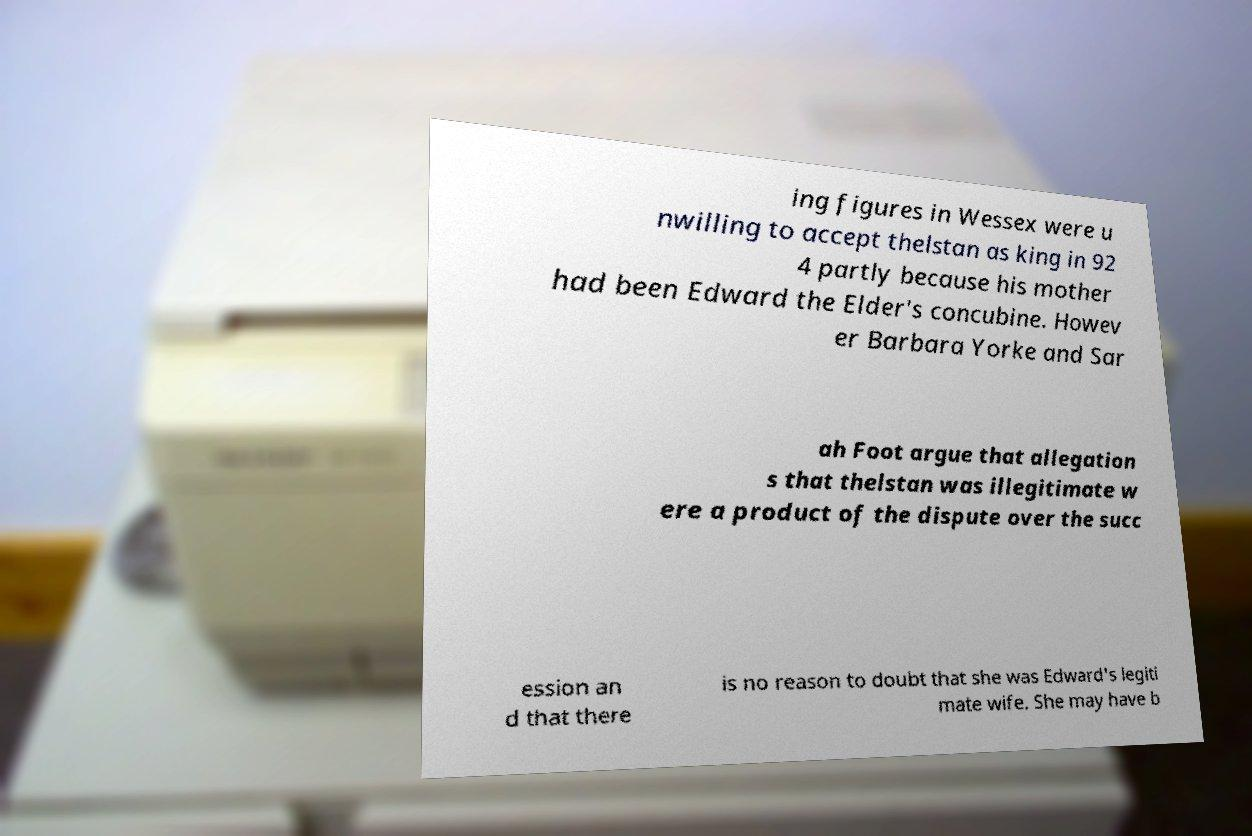Please read and relay the text visible in this image. What does it say? ing figures in Wessex were u nwilling to accept thelstan as king in 92 4 partly because his mother had been Edward the Elder's concubine. Howev er Barbara Yorke and Sar ah Foot argue that allegation s that thelstan was illegitimate w ere a product of the dispute over the succ ession an d that there is no reason to doubt that she was Edward's legiti mate wife. She may have b 